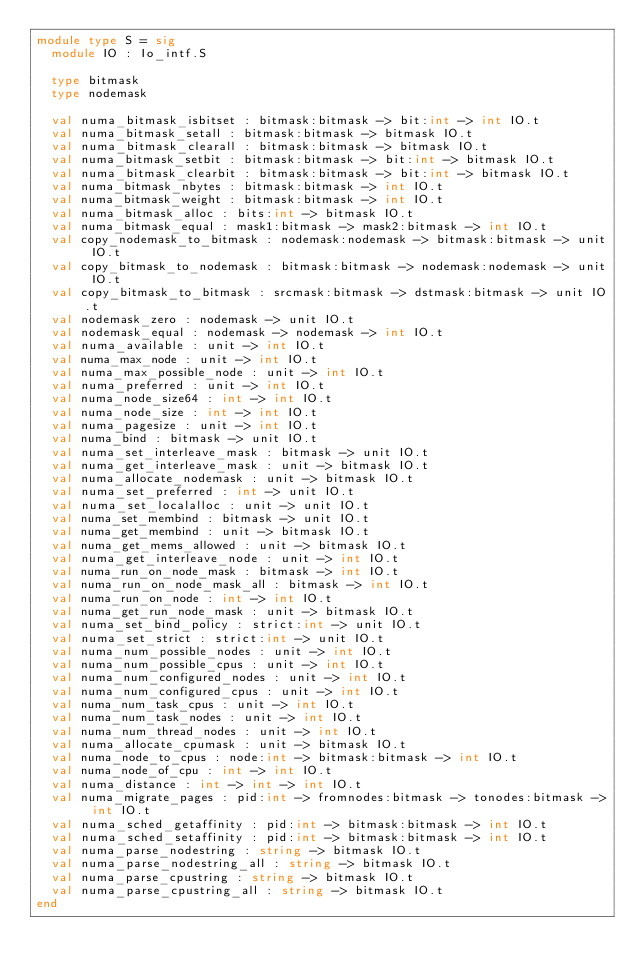Convert code to text. <code><loc_0><loc_0><loc_500><loc_500><_OCaml_>module type S = sig
  module IO : Io_intf.S

  type bitmask
  type nodemask

  val numa_bitmask_isbitset : bitmask:bitmask -> bit:int -> int IO.t
  val numa_bitmask_setall : bitmask:bitmask -> bitmask IO.t
  val numa_bitmask_clearall : bitmask:bitmask -> bitmask IO.t
  val numa_bitmask_setbit : bitmask:bitmask -> bit:int -> bitmask IO.t
  val numa_bitmask_clearbit : bitmask:bitmask -> bit:int -> bitmask IO.t
  val numa_bitmask_nbytes : bitmask:bitmask -> int IO.t
  val numa_bitmask_weight : bitmask:bitmask -> int IO.t
  val numa_bitmask_alloc : bits:int -> bitmask IO.t
  val numa_bitmask_equal : mask1:bitmask -> mask2:bitmask -> int IO.t
  val copy_nodemask_to_bitmask : nodemask:nodemask -> bitmask:bitmask -> unit IO.t
  val copy_bitmask_to_nodemask : bitmask:bitmask -> nodemask:nodemask -> unit IO.t
  val copy_bitmask_to_bitmask : srcmask:bitmask -> dstmask:bitmask -> unit IO.t
  val nodemask_zero : nodemask -> unit IO.t
  val nodemask_equal : nodemask -> nodemask -> int IO.t
  val numa_available : unit -> int IO.t
  val numa_max_node : unit -> int IO.t
  val numa_max_possible_node : unit -> int IO.t
  val numa_preferred : unit -> int IO.t
  val numa_node_size64 : int -> int IO.t
  val numa_node_size : int -> int IO.t
  val numa_pagesize : unit -> int IO.t
  val numa_bind : bitmask -> unit IO.t
  val numa_set_interleave_mask : bitmask -> unit IO.t
  val numa_get_interleave_mask : unit -> bitmask IO.t
  val numa_allocate_nodemask : unit -> bitmask IO.t
  val numa_set_preferred : int -> unit IO.t
  val numa_set_localalloc : unit -> unit IO.t
  val numa_set_membind : bitmask -> unit IO.t
  val numa_get_membind : unit -> bitmask IO.t
  val numa_get_mems_allowed : unit -> bitmask IO.t
  val numa_get_interleave_node : unit -> int IO.t
  val numa_run_on_node_mask : bitmask -> int IO.t
  val numa_run_on_node_mask_all : bitmask -> int IO.t
  val numa_run_on_node : int -> int IO.t
  val numa_get_run_node_mask : unit -> bitmask IO.t
  val numa_set_bind_policy : strict:int -> unit IO.t
  val numa_set_strict : strict:int -> unit IO.t
  val numa_num_possible_nodes : unit -> int IO.t
  val numa_num_possible_cpus : unit -> int IO.t
  val numa_num_configured_nodes : unit -> int IO.t
  val numa_num_configured_cpus : unit -> int IO.t
  val numa_num_task_cpus : unit -> int IO.t
  val numa_num_task_nodes : unit -> int IO.t
  val numa_num_thread_nodes : unit -> int IO.t
  val numa_allocate_cpumask : unit -> bitmask IO.t
  val numa_node_to_cpus : node:int -> bitmask:bitmask -> int IO.t
  val numa_node_of_cpu : int -> int IO.t
  val numa_distance : int -> int -> int IO.t
  val numa_migrate_pages : pid:int -> fromnodes:bitmask -> tonodes:bitmask -> int IO.t
  val numa_sched_getaffinity : pid:int -> bitmask:bitmask -> int IO.t
  val numa_sched_setaffinity : pid:int -> bitmask:bitmask -> int IO.t
  val numa_parse_nodestring : string -> bitmask IO.t
  val numa_parse_nodestring_all : string -> bitmask IO.t
  val numa_parse_cpustring : string -> bitmask IO.t
  val numa_parse_cpustring_all : string -> bitmask IO.t
end
</code> 